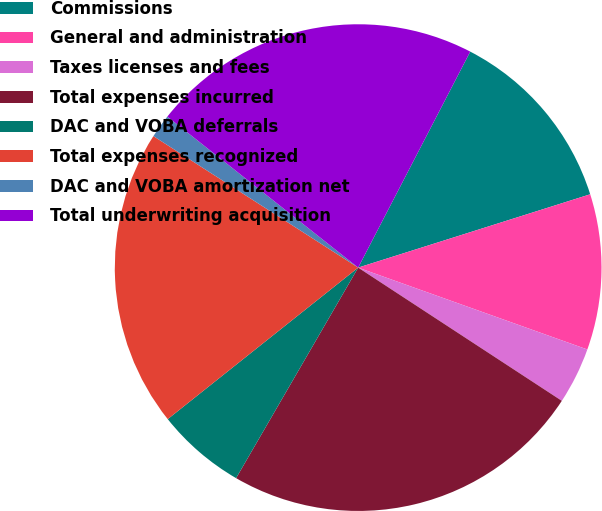Convert chart to OTSL. <chart><loc_0><loc_0><loc_500><loc_500><pie_chart><fcel>Commissions<fcel>General and administration<fcel>Taxes licenses and fees<fcel>Total expenses incurred<fcel>DAC and VOBA deferrals<fcel>Total expenses recognized<fcel>DAC and VOBA amortization net<fcel>Total underwriting acquisition<nl><fcel>12.51%<fcel>10.33%<fcel>3.76%<fcel>24.14%<fcel>5.94%<fcel>19.78%<fcel>1.57%<fcel>21.96%<nl></chart> 